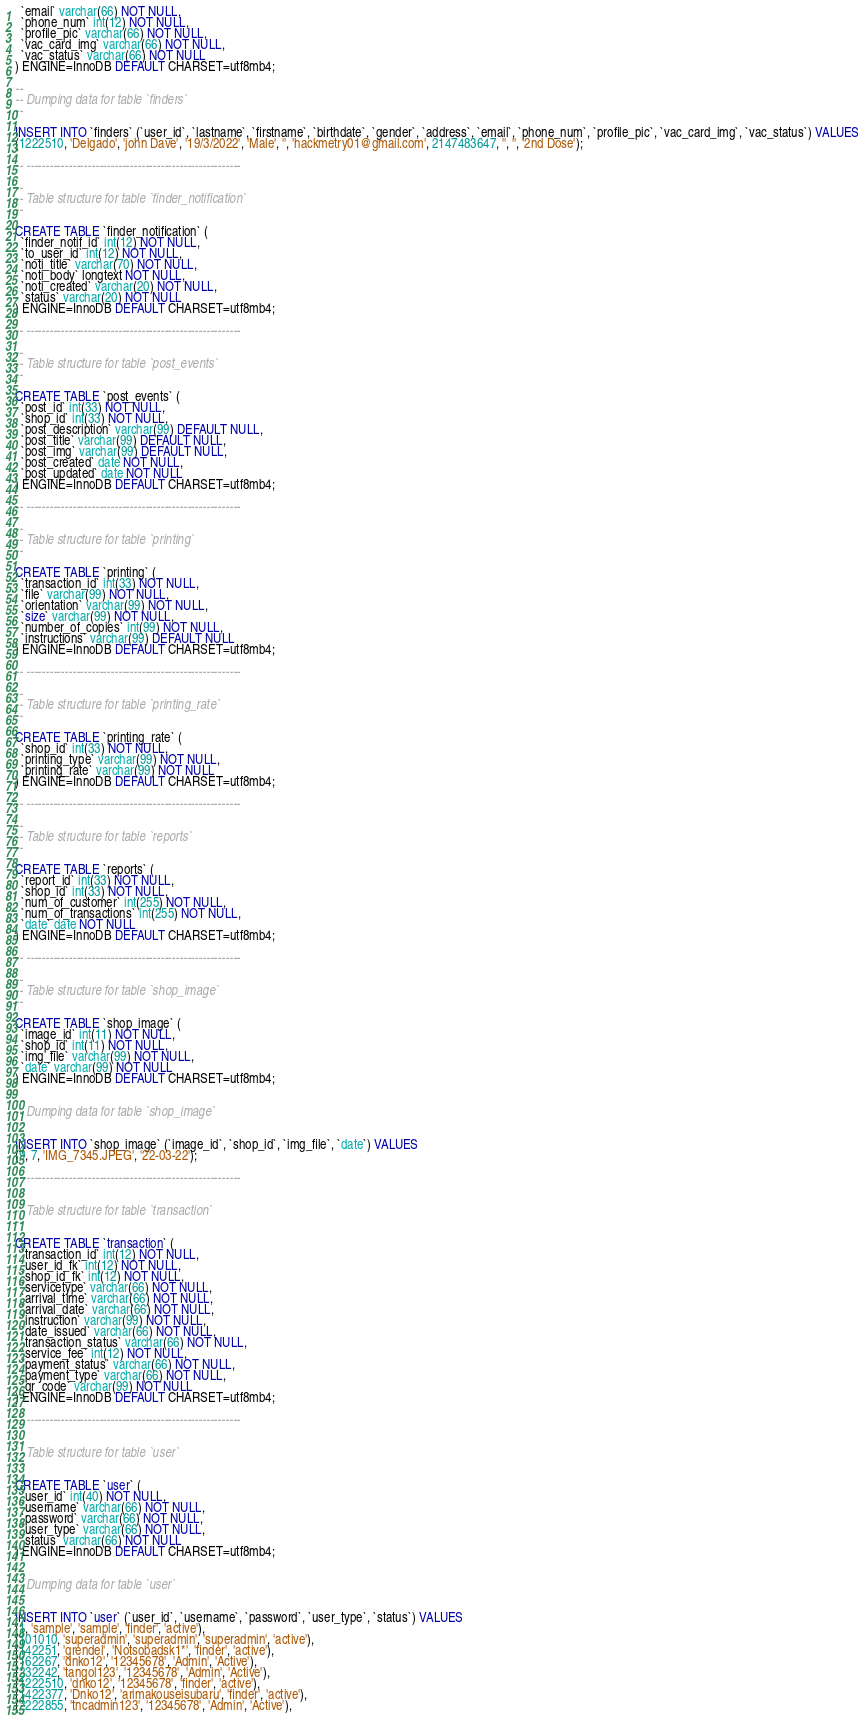<code> <loc_0><loc_0><loc_500><loc_500><_SQL_>  `email` varchar(66) NOT NULL,
  `phone_num` int(12) NOT NULL,
  `profile_pic` varchar(66) NOT NULL,
  `vac_card_img` varchar(66) NOT NULL,
  `vac_status` varchar(66) NOT NULL
) ENGINE=InnoDB DEFAULT CHARSET=utf8mb4;

--
-- Dumping data for table `finders`
--

INSERT INTO `finders` (`user_id`, `lastname`, `firstname`, `birthdate`, `gender`, `address`, `email`, `phone_num`, `profile_pic`, `vac_card_img`, `vac_status`) VALUES
(1222510, 'Delgado', 'john Dave', '19/3/2022', 'Male', '', 'hackmetry01@gmail.com', 2147483647, '', '', '2nd Dose');

-- --------------------------------------------------------

--
-- Table structure for table `finder_notification`
--

CREATE TABLE `finder_notification` (
  `finder_notif_id` int(12) NOT NULL,
  `to_user_id` int(12) NOT NULL,
  `noti_title` varchar(70) NOT NULL,
  `noti_body` longtext NOT NULL,
  `noti_created` varchar(20) NOT NULL,
  `status` varchar(20) NOT NULL
) ENGINE=InnoDB DEFAULT CHARSET=utf8mb4;

-- --------------------------------------------------------

--
-- Table structure for table `post_events`
--

CREATE TABLE `post_events` (
  `post_id` int(33) NOT NULL,
  `shop_id` int(33) NOT NULL,
  `post_description` varchar(99) DEFAULT NULL,
  `post_title` varchar(99) DEFAULT NULL,
  `post_img` varchar(99) DEFAULT NULL,
  `post_created` date NOT NULL,
  `post_updated` date NOT NULL
) ENGINE=InnoDB DEFAULT CHARSET=utf8mb4;

-- --------------------------------------------------------

--
-- Table structure for table `printing`
--

CREATE TABLE `printing` (
  `transaction_id` int(33) NOT NULL,
  `file` varchar(99) NOT NULL,
  `orientation` varchar(99) NOT NULL,
  `size` varchar(99) NOT NULL,
  `number_of_copies` int(99) NOT NULL,
  `instructions` varchar(99) DEFAULT NULL
) ENGINE=InnoDB DEFAULT CHARSET=utf8mb4;

-- --------------------------------------------------------

--
-- Table structure for table `printing_rate`
--

CREATE TABLE `printing_rate` (
  `shop_id` int(33) NOT NULL,
  `printing_type` varchar(99) NOT NULL,
  `printing_rate` varchar(99) NOT NULL
) ENGINE=InnoDB DEFAULT CHARSET=utf8mb4;

-- --------------------------------------------------------

--
-- Table structure for table `reports`
--

CREATE TABLE `reports` (
  `report_id` int(33) NOT NULL,
  `shop_id` int(33) NOT NULL,
  `num_of_customer` int(255) NOT NULL,
  `num_of_transactions` int(255) NOT NULL,
  `date` date NOT NULL
) ENGINE=InnoDB DEFAULT CHARSET=utf8mb4;

-- --------------------------------------------------------

--
-- Table structure for table `shop_image`
--

CREATE TABLE `shop_image` (
  `image_id` int(11) NOT NULL,
  `shop_id` int(11) NOT NULL,
  `img_file` varchar(99) NOT NULL,
  `date` varchar(99) NOT NULL
) ENGINE=InnoDB DEFAULT CHARSET=utf8mb4;

--
-- Dumping data for table `shop_image`
--

INSERT INTO `shop_image` (`image_id`, `shop_id`, `img_file`, `date`) VALUES
(9, 7, 'IMG_7345.JPEG', '22-03-22');

-- --------------------------------------------------------

--
-- Table structure for table `transaction`
--

CREATE TABLE `transaction` (
  `transaction_id` int(12) NOT NULL,
  `user_id_fk` int(12) NOT NULL,
  `shop_id_fk` int(12) NOT NULL,
  `servicetype` varchar(66) NOT NULL,
  `arrival_time` varchar(66) NOT NULL,
  `arrival_date` varchar(66) NOT NULL,
  `instruction` varchar(99) NOT NULL,
  `date_issued` varchar(66) NOT NULL,
  `transaction_status` varchar(66) NOT NULL,
  `service_fee` int(12) NOT NULL,
  `payment_status` varchar(66) NOT NULL,
  `payment_type` varchar(66) NOT NULL,
  `qr_code` varchar(99) NOT NULL
) ENGINE=InnoDB DEFAULT CHARSET=utf8mb4;

-- --------------------------------------------------------

--
-- Table structure for table `user`
--

CREATE TABLE `user` (
  `user_id` int(40) NOT NULL,
  `username` varchar(66) NOT NULL,
  `password` varchar(66) NOT NULL,
  `user_type` varchar(66) NOT NULL,
  `status` varchar(66) NOT NULL
) ENGINE=InnoDB DEFAULT CHARSET=utf8mb4;

--
-- Dumping data for table `user`
--

INSERT INTO `user` (`user_id`, `username`, `password`, `user_type`, `status`) VALUES
(1, 'sample', 'sample', 'finder', 'active'),
(101010, 'superadmin', 'superadmin', 'superadmin', 'active'),
(142251, 'grendel', 'Notsobadsk1*', 'finder', 'active'),
(162267, 'dnko12', '12345678', 'Admin', 'Active'),
(232242, 'tangol123', '12345678', 'Admin', 'Active'),
(1222510, 'dnko12', '12345678', 'finder', 'active'),
(1422377, 'Dnko12', 'arimakouseisubaru', 'finder', 'active'),
(2222855, 'tncadmin123', '12345678', 'Admin', 'Active'),</code> 